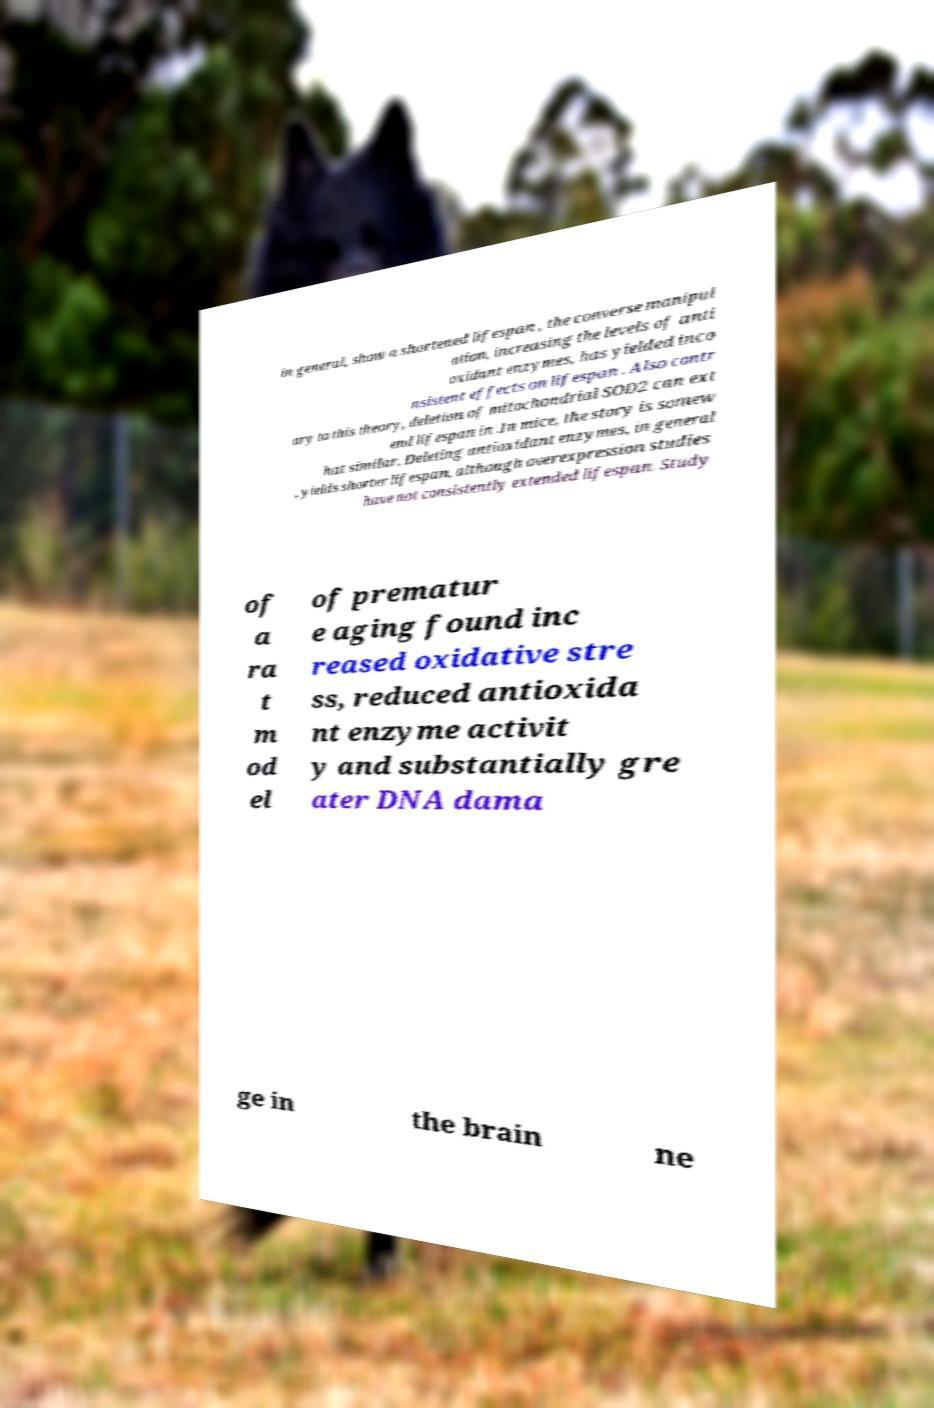I need the written content from this picture converted into text. Can you do that? in general, show a shortened lifespan , the converse manipul ation, increasing the levels of anti oxidant enzymes, has yielded inco nsistent effects on lifespan . Also contr ary to this theory, deletion of mitochondrial SOD2 can ext end lifespan in .In mice, the story is somew hat similar. Deleting antioxidant enzymes, in general , yields shorter lifespan, although overexpression studies have not consistently extended lifespan. Study of a ra t m od el of prematur e aging found inc reased oxidative stre ss, reduced antioxida nt enzyme activit y and substantially gre ater DNA dama ge in the brain ne 